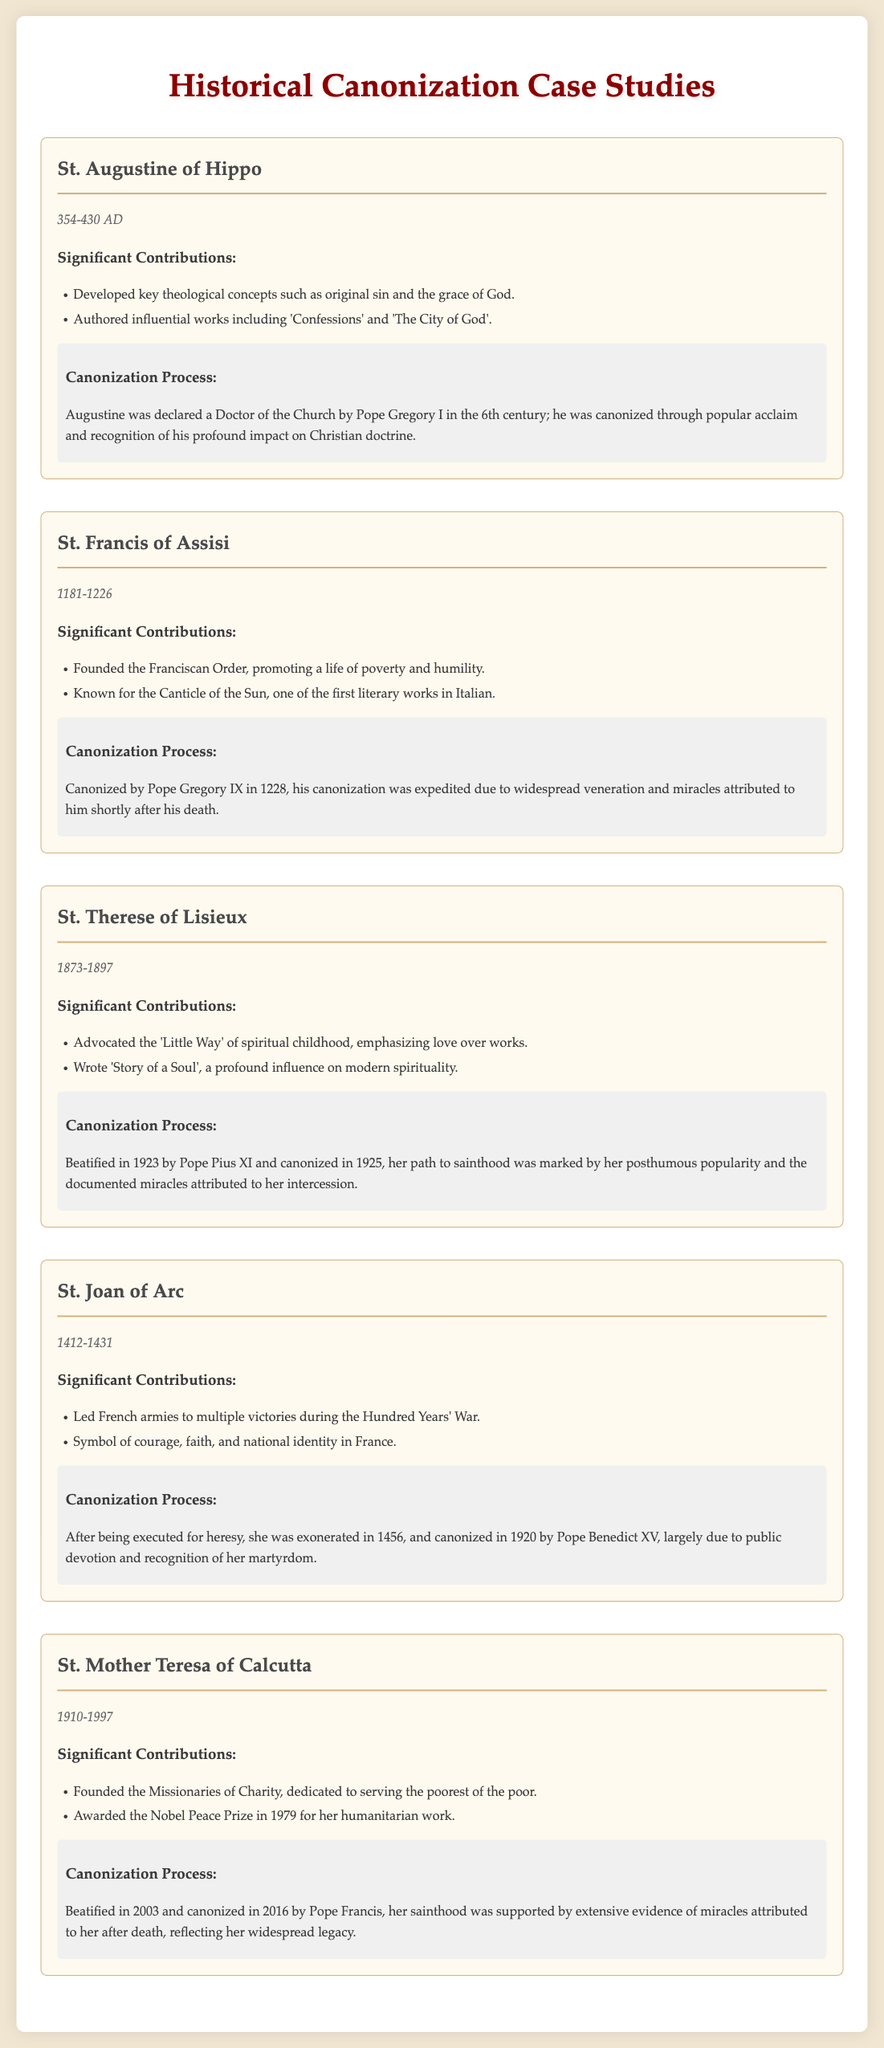What is the lifetime of St. Augustine of Hippo? The document provides the lifetime of St. Augustine of Hippo as 354-430 AD.
Answer: 354-430 AD Who canonized St. Francis of Assisi? The document states that St. Francis of Assisi was canonized by Pope Gregory IX.
Answer: Pope Gregory IX What significant work did St. Therese of Lisieux write? The document mentions that St. Therese of Lisieux wrote 'Story of a Soul'.
Answer: 'Story of a Soul' In which year was St. Joan of Arc canonized? According to the document, St. Joan of Arc was canonized in 1920.
Answer: 1920 What was the primary focus of St. Mother Teresa of Calcutta's work? The document indicates that St. Mother Teresa focused on serving the poorest of the poor.
Answer: Serving the poorest of the poor What is a common theme among the canonization processes listed? The document highlights that widespread veneration and miracles attributed to saints played a significant role in their canonization processes.
Answer: Widespread veneration and miracles Which saint is known for the 'Little Way'? The document states that St. Therese of Lisieux advocated the 'Little Way'.
Answer: St. Therese of Lisieux What was the primary order founded by St. Francis of Assisi? The document mentions that St. Francis of Assisi founded the Franciscan Order.
Answer: Franciscan Order 